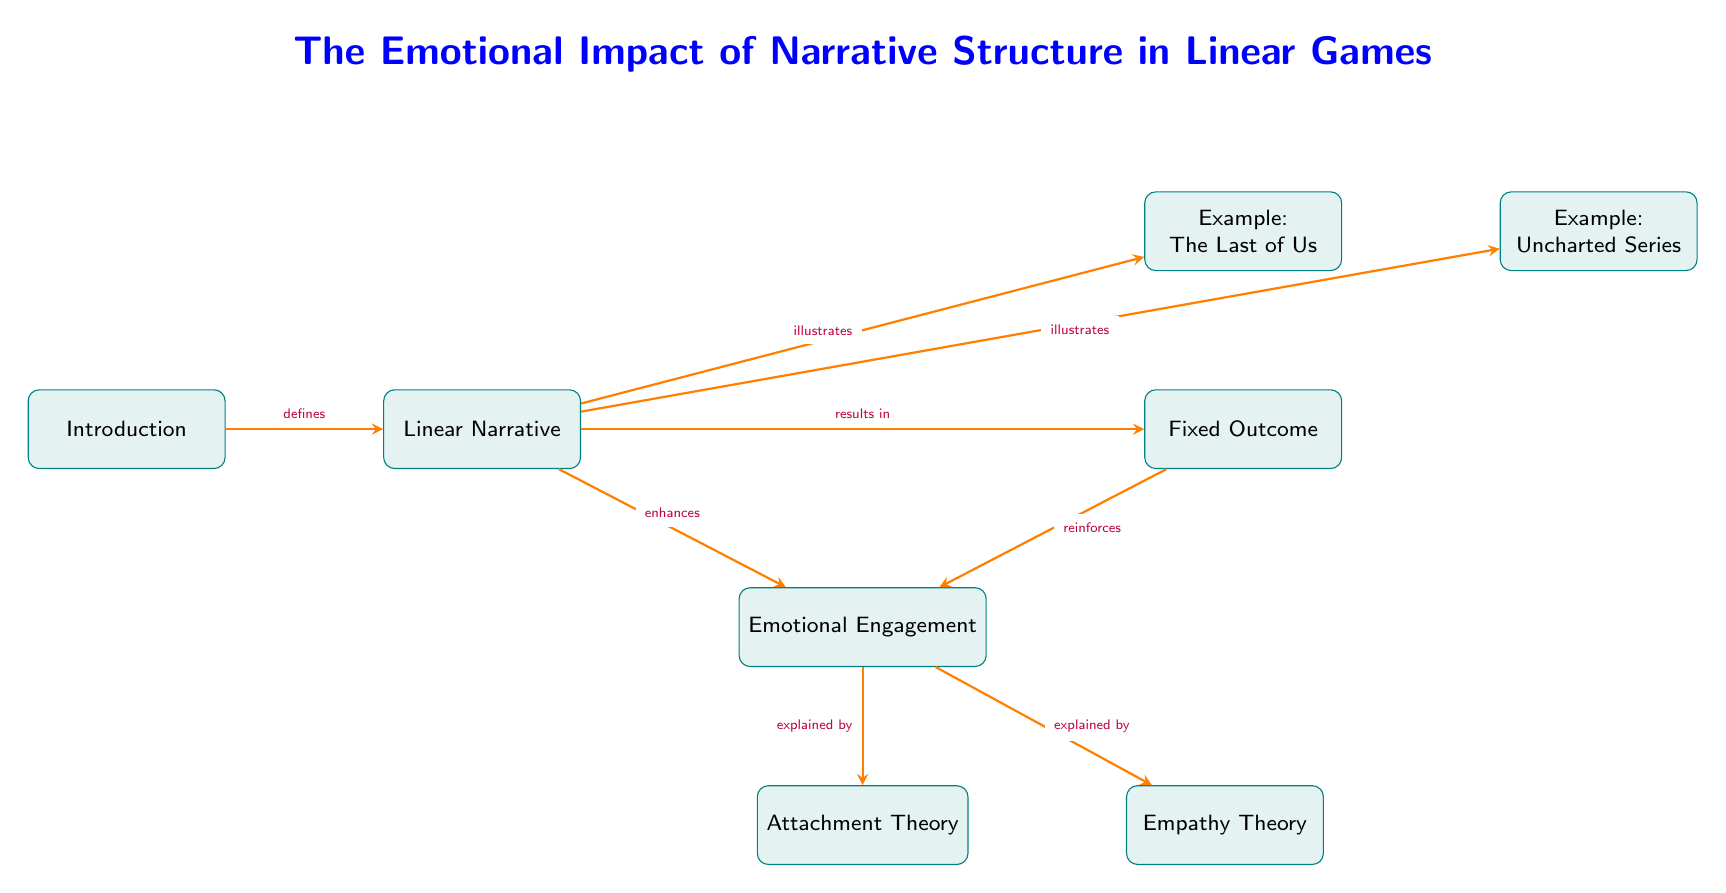What defines the linear narrative? The diagram shows that the introduction defines the linear narrative, indicating that it is the initial step or component in establishing a linear storytelling structure.
Answer: Introduction What do linear narratives result in? According to the diagram, linear narratives result in a fixed outcome, meaning that the story concludes in a predetermined manner without multiple endings.
Answer: Fixed Outcome Which example is illustrated from the linear narrative? The diagram indicates that both "The Last of Us" and "Uncharted Series" are examples that illustrate the concept of linear narrative. Therefore, any of these could be an acceptable response; in this case, we'll use the first example mentioned.
Answer: The Last of Us What enhances emotional engagement? The linear narrative enhances emotional engagement, as shown by the connection in the diagram, which suggests that a structured narrative can lead to a deeper emotional involvement for players.
Answer: Emotional Engagement What psychological theory explains emotional engagement related to attachment? The attachment theory is listed in the diagram as a psychological concept that explains emotional engagement in the context of linear narratives, highlighting the emotional bonds players form with characters.
Answer: Attachment Theory What relationship exists between fixed outcomes and emotional engagement? The diagram illustrates that fixed outcomes reinforce emotional engagement, meaning that knowing the story will conclude in a specific way can strengthen the emotional ties players have with it.
Answer: Reinforces How many total nodes are there in the diagram? By counting the nodes presented in the diagram, we can find that there are a total of six nodes, as depicted in the structure.
Answer: Six Which arrow indicates an explanation by empathy theory? The diagram shows an arrow from emotional engagement to empathy theory, indicating that emotional engagement is explained by this psychological concept, thus connecting the two ideas.
Answer: Empathy Theory What is the title of the diagram? The title of the diagram, which provides an overview of the content, is "The Emotional Impact of Narrative Structure in Linear Games."
Answer: The Emotional Impact of Narrative Structure in Linear Games What relationship does the linear narrative have with the last of us? The diagram indicates that the linear narrative illustrates "The Last of Us", signifying that this game is an example within the context of structured storytelling.
Answer: Illustrates 